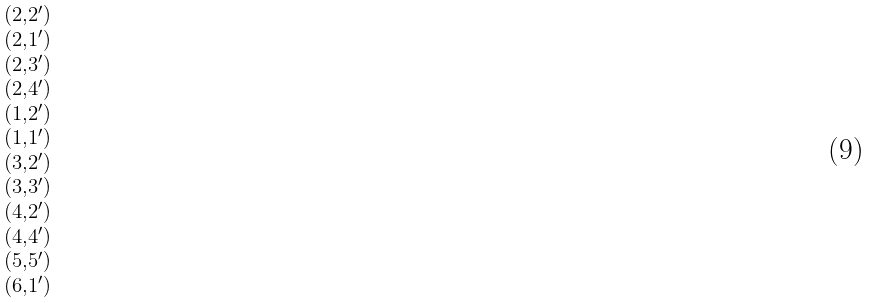Convert formula to latex. <formula><loc_0><loc_0><loc_500><loc_500>\begin{smallmatrix} ( 2 , 2 ^ { \prime } ) \\ ( 2 , 1 ^ { \prime } ) \\ ( 2 , 3 ^ { \prime } ) \\ ( 2 , 4 ^ { \prime } ) \\ ( 1 , 2 ^ { \prime } ) \\ ( 1 , 1 ^ { \prime } ) \\ ( 3 , 2 ^ { \prime } ) \\ ( 3 , 3 ^ { \prime } ) \\ ( 4 , 2 ^ { \prime } ) \\ ( 4 , 4 ^ { \prime } ) \\ ( 5 , 5 ^ { \prime } ) \\ ( 6 , 1 ^ { \prime } ) \\ \end{smallmatrix}</formula> 